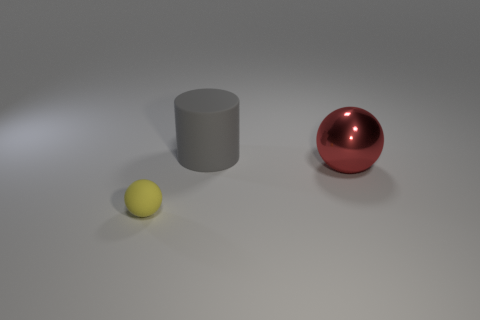Add 3 small blue balls. How many objects exist? 6 Subtract all spheres. How many objects are left? 1 Subtract 0 brown balls. How many objects are left? 3 Subtract 1 balls. How many balls are left? 1 Subtract all blue balls. Subtract all red cylinders. How many balls are left? 2 Subtract all green blocks. How many blue balls are left? 0 Subtract all cyan metal things. Subtract all shiny objects. How many objects are left? 2 Add 3 large gray things. How many large gray things are left? 4 Add 1 tiny metallic cylinders. How many tiny metallic cylinders exist? 1 